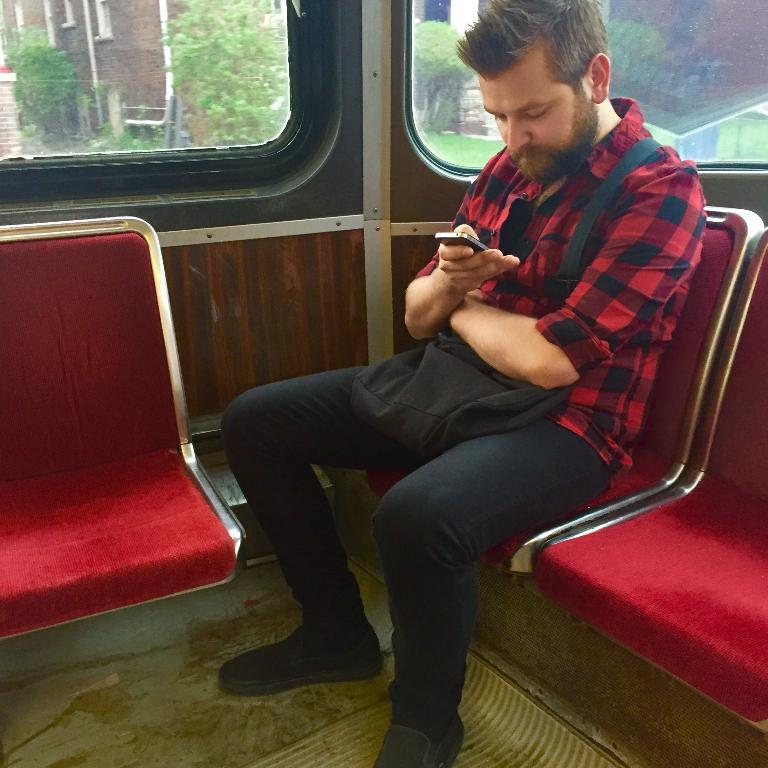Who is present in the image? There is a man in the image. What is the man doing in the image? The man is sitting on a chair. What is the man wearing in the image? The man is wearing a bag. What can be seen in the background of the image? There are trees and a building in the background of the image. What type of record can be seen on the chair next to the man? There is no record present in the image; the man is sitting on a chair with no additional objects mentioned. 